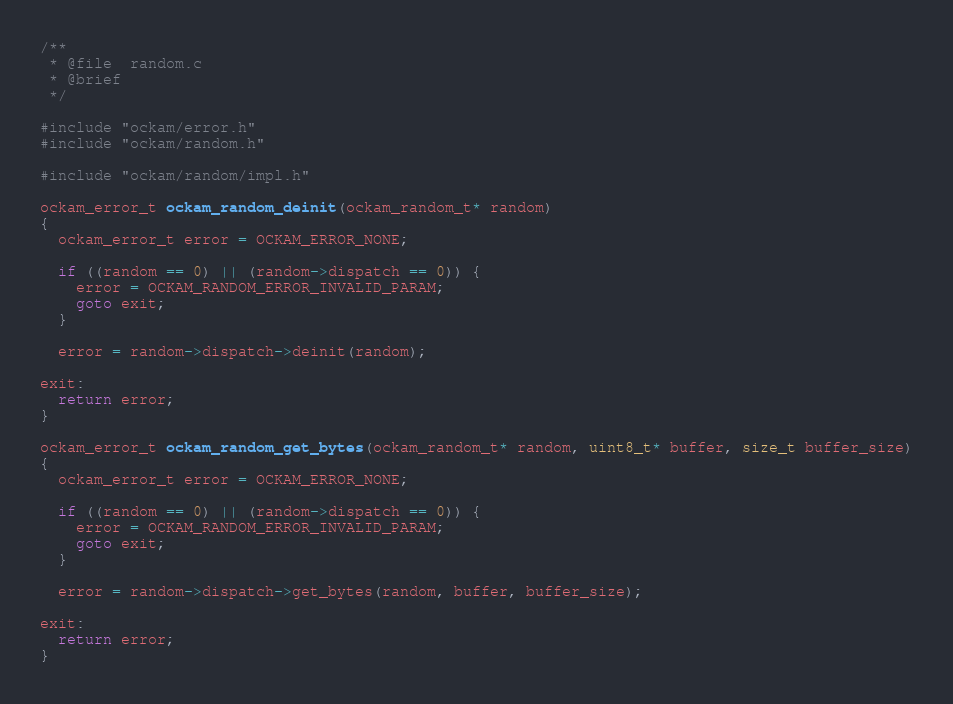<code> <loc_0><loc_0><loc_500><loc_500><_C_>/**
 * @file  random.c
 * @brief
 */

#include "ockam/error.h"
#include "ockam/random.h"

#include "ockam/random/impl.h"

ockam_error_t ockam_random_deinit(ockam_random_t* random)
{
  ockam_error_t error = OCKAM_ERROR_NONE;

  if ((random == 0) || (random->dispatch == 0)) {
    error = OCKAM_RANDOM_ERROR_INVALID_PARAM;
    goto exit;
  }

  error = random->dispatch->deinit(random);

exit:
  return error;
}

ockam_error_t ockam_random_get_bytes(ockam_random_t* random, uint8_t* buffer, size_t buffer_size)
{
  ockam_error_t error = OCKAM_ERROR_NONE;

  if ((random == 0) || (random->dispatch == 0)) {
    error = OCKAM_RANDOM_ERROR_INVALID_PARAM;
    goto exit;
  }

  error = random->dispatch->get_bytes(random, buffer, buffer_size);

exit:
  return error;
}
</code> 